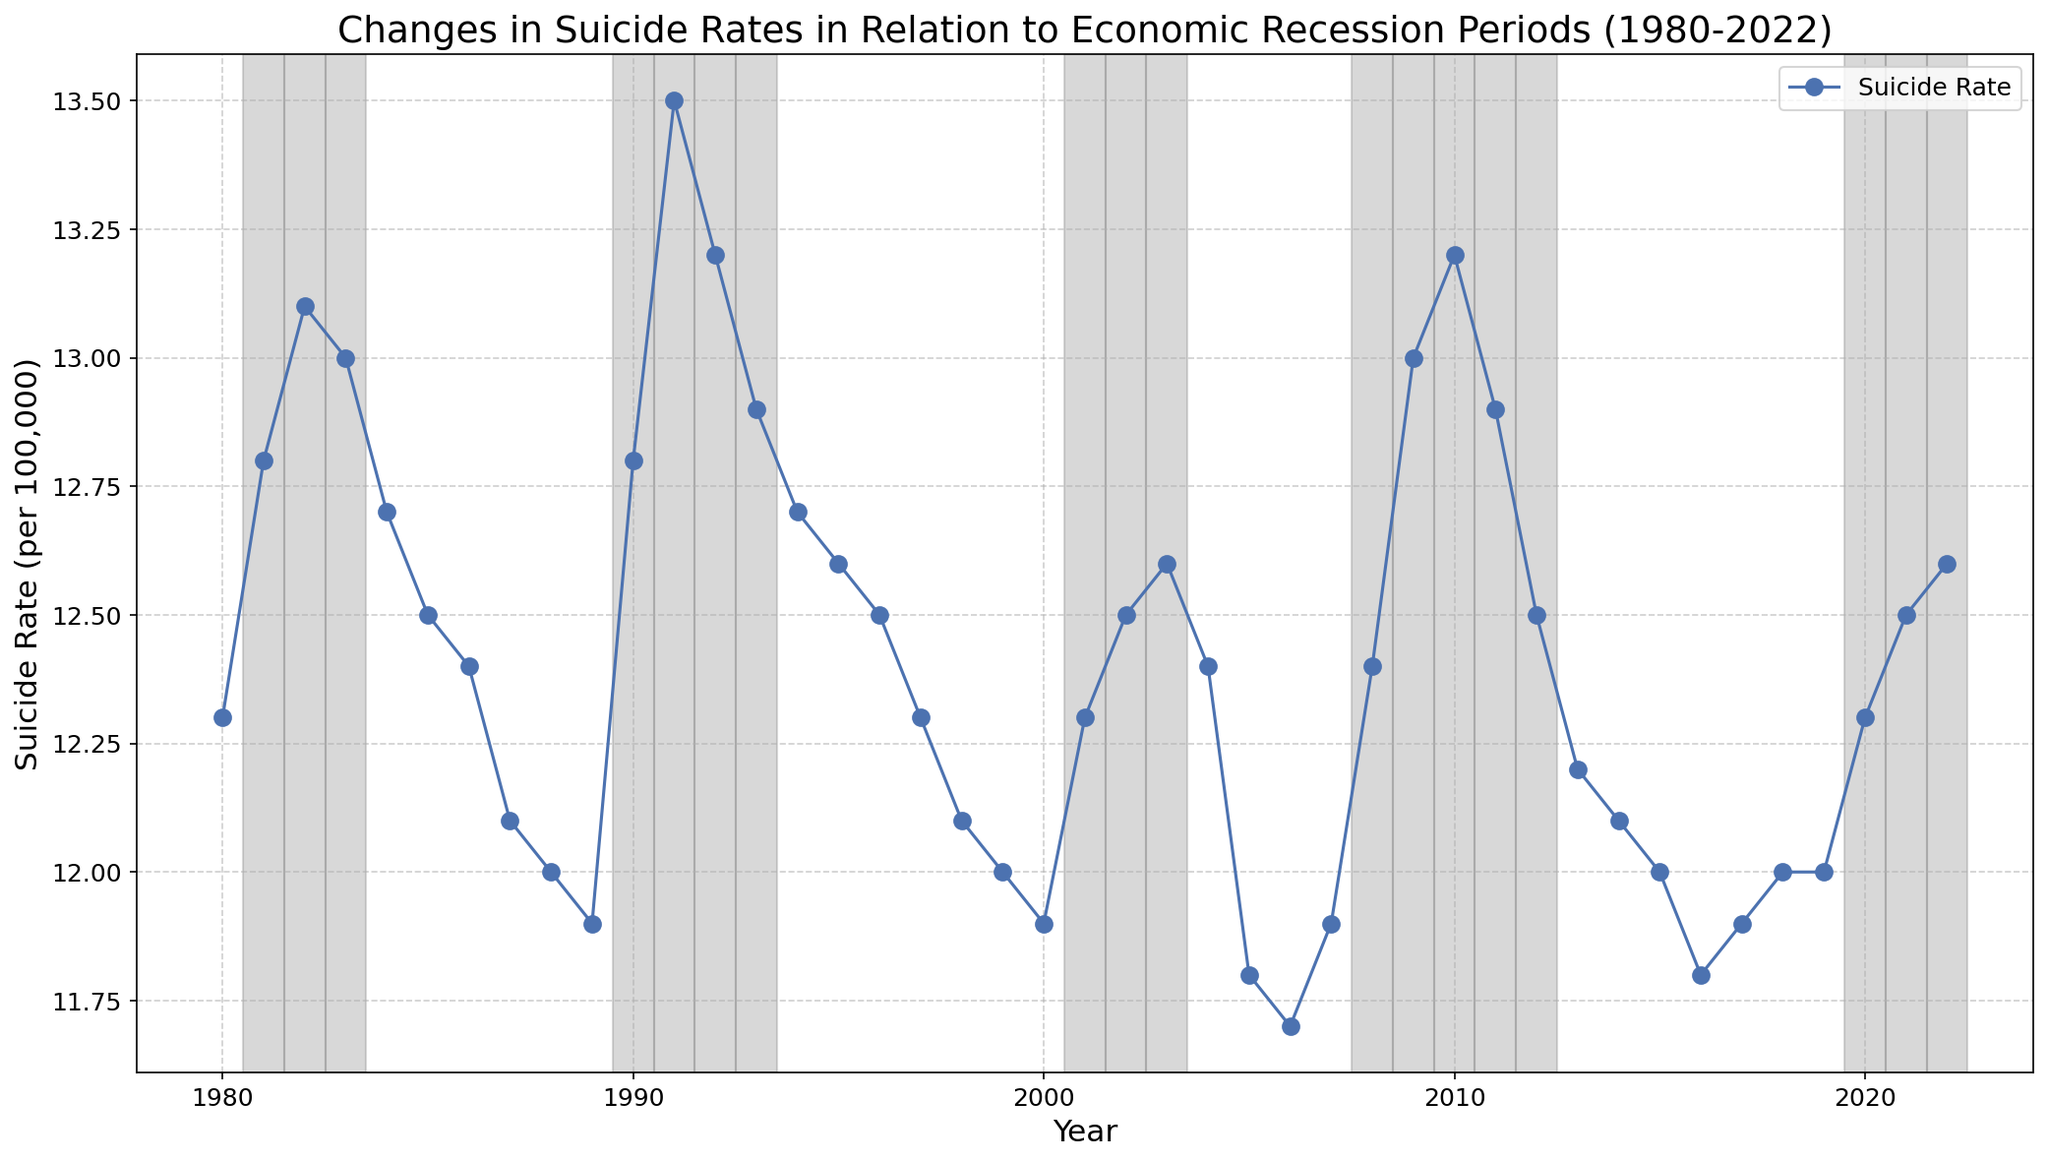What is the trend in suicide rates during recession periods from 1980 to 2022? To identify the trend during recession periods, look at the years where the recession period is marked (gray shaded areas). Observe whether the suicide rate generally increases, decreases, or remains stable during these periods. In most recession periods, the suicide rate seems to increase or remain higher than in non-recession periods. For example, from 1980 to 1983, 1990 to 1993, and 2008 to 2012, the rates are generally higher than other periods.
Answer: The trend is generally an increase How does the suicide rate in 1982 compare to that in 2010? Find the suicide rates for the years 1982 and 2010 on the line chart. In 1982, the rate is 13.1, and in 2010, it is 13.2. Both values are very close but 2010 has a slightly higher rate.
Answer: 2010 is slightly higher During which non-recession period did the suicide rate reach its lowest value? Look for the lowest suicide rate in years marked as "No" for recession period. According to the data, the lowest rate in non-recession periods is in 2005 and 2006, with a rate of 11.7.
Answer: 2005 and 2006 What is the median suicide rate during recession periods from 1980 to 2022? List out the suicide rates during recession periods: 12.8, 13.1, 13.0, 12.8, 13.5, 13.2, 12.9, 12.3, 12.5, 12.6, 12.4, 13.0, 13.2, 12.9, 12.5, 12.3, 12.5, and 12.6. Sort these values in ascending order: 12.3, 12.3, 12.4, 12.5, 12.5, 12.6, 12.6, 12.8, 12.8, 12.9, 12.9, 13.0, 13.0, 13.1, 13.2, 13.2, 13.5. The median value is the middle value when sorted, which here is 12.8.
Answer: 12.8 Did the suicide rate increase or decrease after the recession in 2008-2012? Look at the suicide rates in 2008-2012 and compare them with the following years immediately after this period. The rates in 2008-2012 are higher (12.4 to 13.2) and then it decreases to 12.2 in 2013 and remains lower through the following years.
Answer: Decrease 